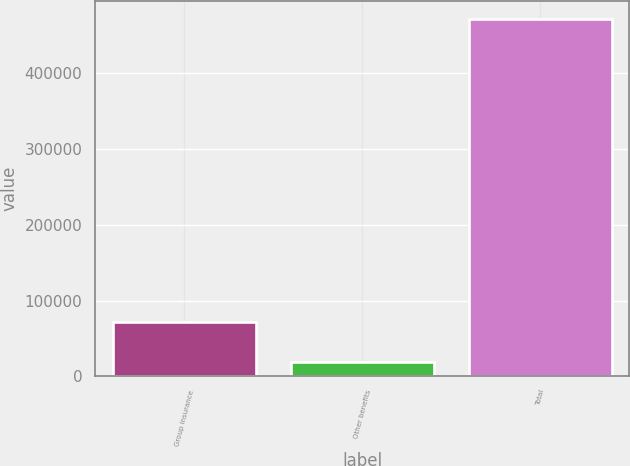<chart> <loc_0><loc_0><loc_500><loc_500><bar_chart><fcel>Group insurance<fcel>Other benefits<fcel>Total<nl><fcel>71103<fcel>18303<fcel>472075<nl></chart> 